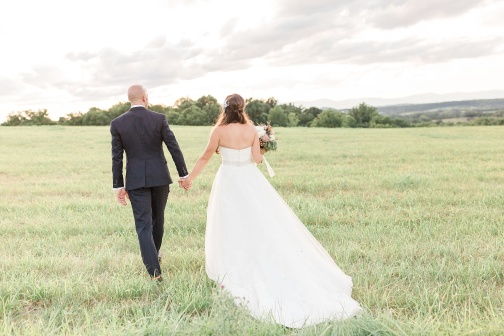Analyze the image in a comprehensive and detailed manner. In the image, a couple is seen walking hand in hand through a lush, green field. The man is wearing a black suit, and the woman is dressed in a beautiful white wedding gown. They are walking away from the camera, moving towards the horizon. The woman holds a bouquet of flowers delicately in her right hand. The expansive green field around them is vibrant and rich, contrasting with the blue sky above, which is dotted with fluffy white clouds. The overall scene exudes a sense of peace and togetherness, capturing the couple as they embark on a new journey in life, symbolizing unity and future endeavors. 